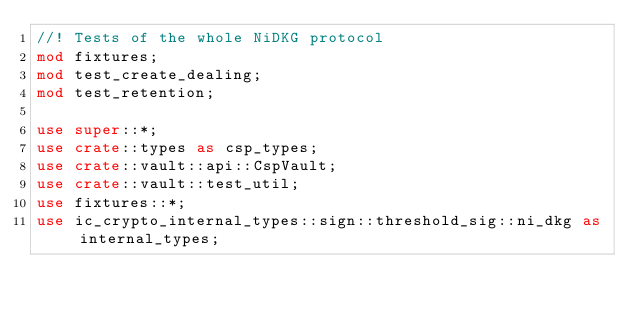<code> <loc_0><loc_0><loc_500><loc_500><_Rust_>//! Tests of the whole NiDKG protocol
mod fixtures;
mod test_create_dealing;
mod test_retention;

use super::*;
use crate::types as csp_types;
use crate::vault::api::CspVault;
use crate::vault::test_util;
use fixtures::*;
use ic_crypto_internal_types::sign::threshold_sig::ni_dkg as internal_types;</code> 